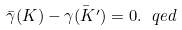Convert formula to latex. <formula><loc_0><loc_0><loc_500><loc_500>\bar { \gamma } ( K ) - \bar { \gamma ( K ^ { \prime } ) } = 0 . \ q e d</formula> 